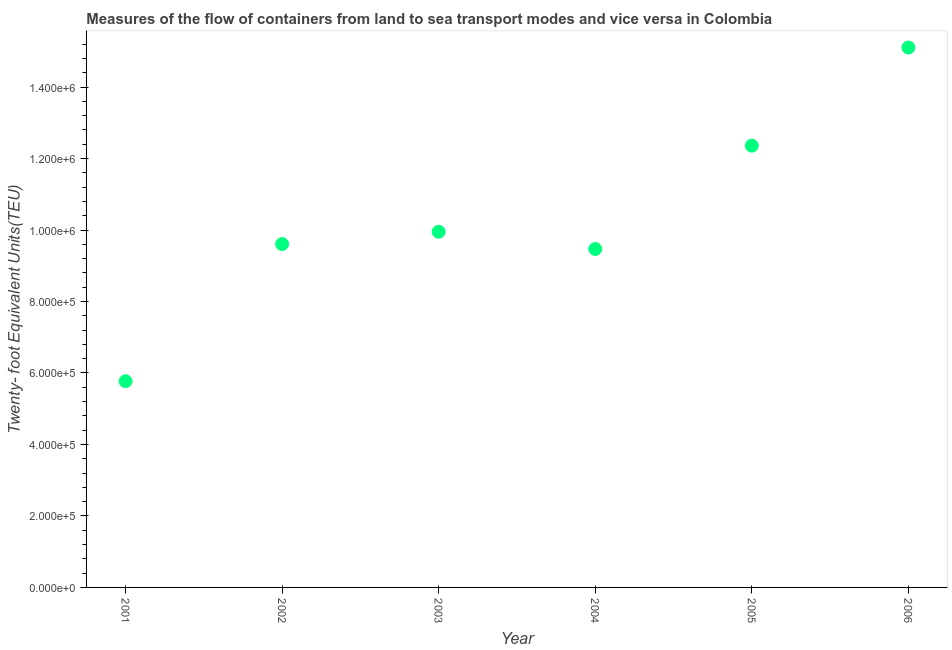What is the container port traffic in 2001?
Provide a short and direct response. 5.77e+05. Across all years, what is the maximum container port traffic?
Your response must be concise. 1.51e+06. Across all years, what is the minimum container port traffic?
Give a very brief answer. 5.77e+05. In which year was the container port traffic maximum?
Ensure brevity in your answer.  2006. In which year was the container port traffic minimum?
Provide a short and direct response. 2001. What is the sum of the container port traffic?
Provide a short and direct response. 6.23e+06. What is the difference between the container port traffic in 2005 and 2006?
Your response must be concise. -2.75e+05. What is the average container port traffic per year?
Make the answer very short. 1.04e+06. What is the median container port traffic?
Give a very brief answer. 9.78e+05. Do a majority of the years between 2003 and 2006 (inclusive) have container port traffic greater than 400000 TEU?
Your answer should be compact. Yes. What is the ratio of the container port traffic in 2003 to that in 2006?
Make the answer very short. 0.66. What is the difference between the highest and the second highest container port traffic?
Offer a very short reply. 2.75e+05. Is the sum of the container port traffic in 2005 and 2006 greater than the maximum container port traffic across all years?
Offer a terse response. Yes. What is the difference between the highest and the lowest container port traffic?
Your answer should be very brief. 9.34e+05. Does the container port traffic monotonically increase over the years?
Your response must be concise. No. How many dotlines are there?
Ensure brevity in your answer.  1. How many years are there in the graph?
Your answer should be very brief. 6. What is the difference between two consecutive major ticks on the Y-axis?
Your response must be concise. 2.00e+05. Are the values on the major ticks of Y-axis written in scientific E-notation?
Provide a short and direct response. Yes. Does the graph contain any zero values?
Provide a succinct answer. No. Does the graph contain grids?
Offer a very short reply. No. What is the title of the graph?
Provide a short and direct response. Measures of the flow of containers from land to sea transport modes and vice versa in Colombia. What is the label or title of the Y-axis?
Provide a succinct answer. Twenty- foot Equivalent Units(TEU). What is the Twenty- foot Equivalent Units(TEU) in 2001?
Make the answer very short. 5.77e+05. What is the Twenty- foot Equivalent Units(TEU) in 2002?
Your answer should be compact. 9.61e+05. What is the Twenty- foot Equivalent Units(TEU) in 2003?
Provide a short and direct response. 9.95e+05. What is the Twenty- foot Equivalent Units(TEU) in 2004?
Make the answer very short. 9.47e+05. What is the Twenty- foot Equivalent Units(TEU) in 2005?
Provide a succinct answer. 1.24e+06. What is the Twenty- foot Equivalent Units(TEU) in 2006?
Your answer should be compact. 1.51e+06. What is the difference between the Twenty- foot Equivalent Units(TEU) in 2001 and 2002?
Give a very brief answer. -3.84e+05. What is the difference between the Twenty- foot Equivalent Units(TEU) in 2001 and 2003?
Make the answer very short. -4.18e+05. What is the difference between the Twenty- foot Equivalent Units(TEU) in 2001 and 2004?
Offer a very short reply. -3.70e+05. What is the difference between the Twenty- foot Equivalent Units(TEU) in 2001 and 2005?
Offer a terse response. -6.59e+05. What is the difference between the Twenty- foot Equivalent Units(TEU) in 2001 and 2006?
Make the answer very short. -9.34e+05. What is the difference between the Twenty- foot Equivalent Units(TEU) in 2002 and 2003?
Keep it short and to the point. -3.45e+04. What is the difference between the Twenty- foot Equivalent Units(TEU) in 2002 and 2004?
Make the answer very short. 1.38e+04. What is the difference between the Twenty- foot Equivalent Units(TEU) in 2002 and 2005?
Provide a short and direct response. -2.75e+05. What is the difference between the Twenty- foot Equivalent Units(TEU) in 2002 and 2006?
Your answer should be very brief. -5.50e+05. What is the difference between the Twenty- foot Equivalent Units(TEU) in 2003 and 2004?
Provide a short and direct response. 4.83e+04. What is the difference between the Twenty- foot Equivalent Units(TEU) in 2003 and 2005?
Offer a very short reply. -2.41e+05. What is the difference between the Twenty- foot Equivalent Units(TEU) in 2003 and 2006?
Provide a succinct answer. -5.16e+05. What is the difference between the Twenty- foot Equivalent Units(TEU) in 2004 and 2005?
Offer a very short reply. -2.89e+05. What is the difference between the Twenty- foot Equivalent Units(TEU) in 2004 and 2006?
Give a very brief answer. -5.64e+05. What is the difference between the Twenty- foot Equivalent Units(TEU) in 2005 and 2006?
Make the answer very short. -2.75e+05. What is the ratio of the Twenty- foot Equivalent Units(TEU) in 2001 to that in 2002?
Your answer should be very brief. 0.6. What is the ratio of the Twenty- foot Equivalent Units(TEU) in 2001 to that in 2003?
Provide a short and direct response. 0.58. What is the ratio of the Twenty- foot Equivalent Units(TEU) in 2001 to that in 2004?
Provide a succinct answer. 0.61. What is the ratio of the Twenty- foot Equivalent Units(TEU) in 2001 to that in 2005?
Keep it short and to the point. 0.47. What is the ratio of the Twenty- foot Equivalent Units(TEU) in 2001 to that in 2006?
Give a very brief answer. 0.38. What is the ratio of the Twenty- foot Equivalent Units(TEU) in 2002 to that in 2005?
Keep it short and to the point. 0.78. What is the ratio of the Twenty- foot Equivalent Units(TEU) in 2002 to that in 2006?
Offer a very short reply. 0.64. What is the ratio of the Twenty- foot Equivalent Units(TEU) in 2003 to that in 2004?
Ensure brevity in your answer.  1.05. What is the ratio of the Twenty- foot Equivalent Units(TEU) in 2003 to that in 2005?
Offer a very short reply. 0.81. What is the ratio of the Twenty- foot Equivalent Units(TEU) in 2003 to that in 2006?
Provide a succinct answer. 0.66. What is the ratio of the Twenty- foot Equivalent Units(TEU) in 2004 to that in 2005?
Your answer should be compact. 0.77. What is the ratio of the Twenty- foot Equivalent Units(TEU) in 2004 to that in 2006?
Offer a very short reply. 0.63. What is the ratio of the Twenty- foot Equivalent Units(TEU) in 2005 to that in 2006?
Ensure brevity in your answer.  0.82. 